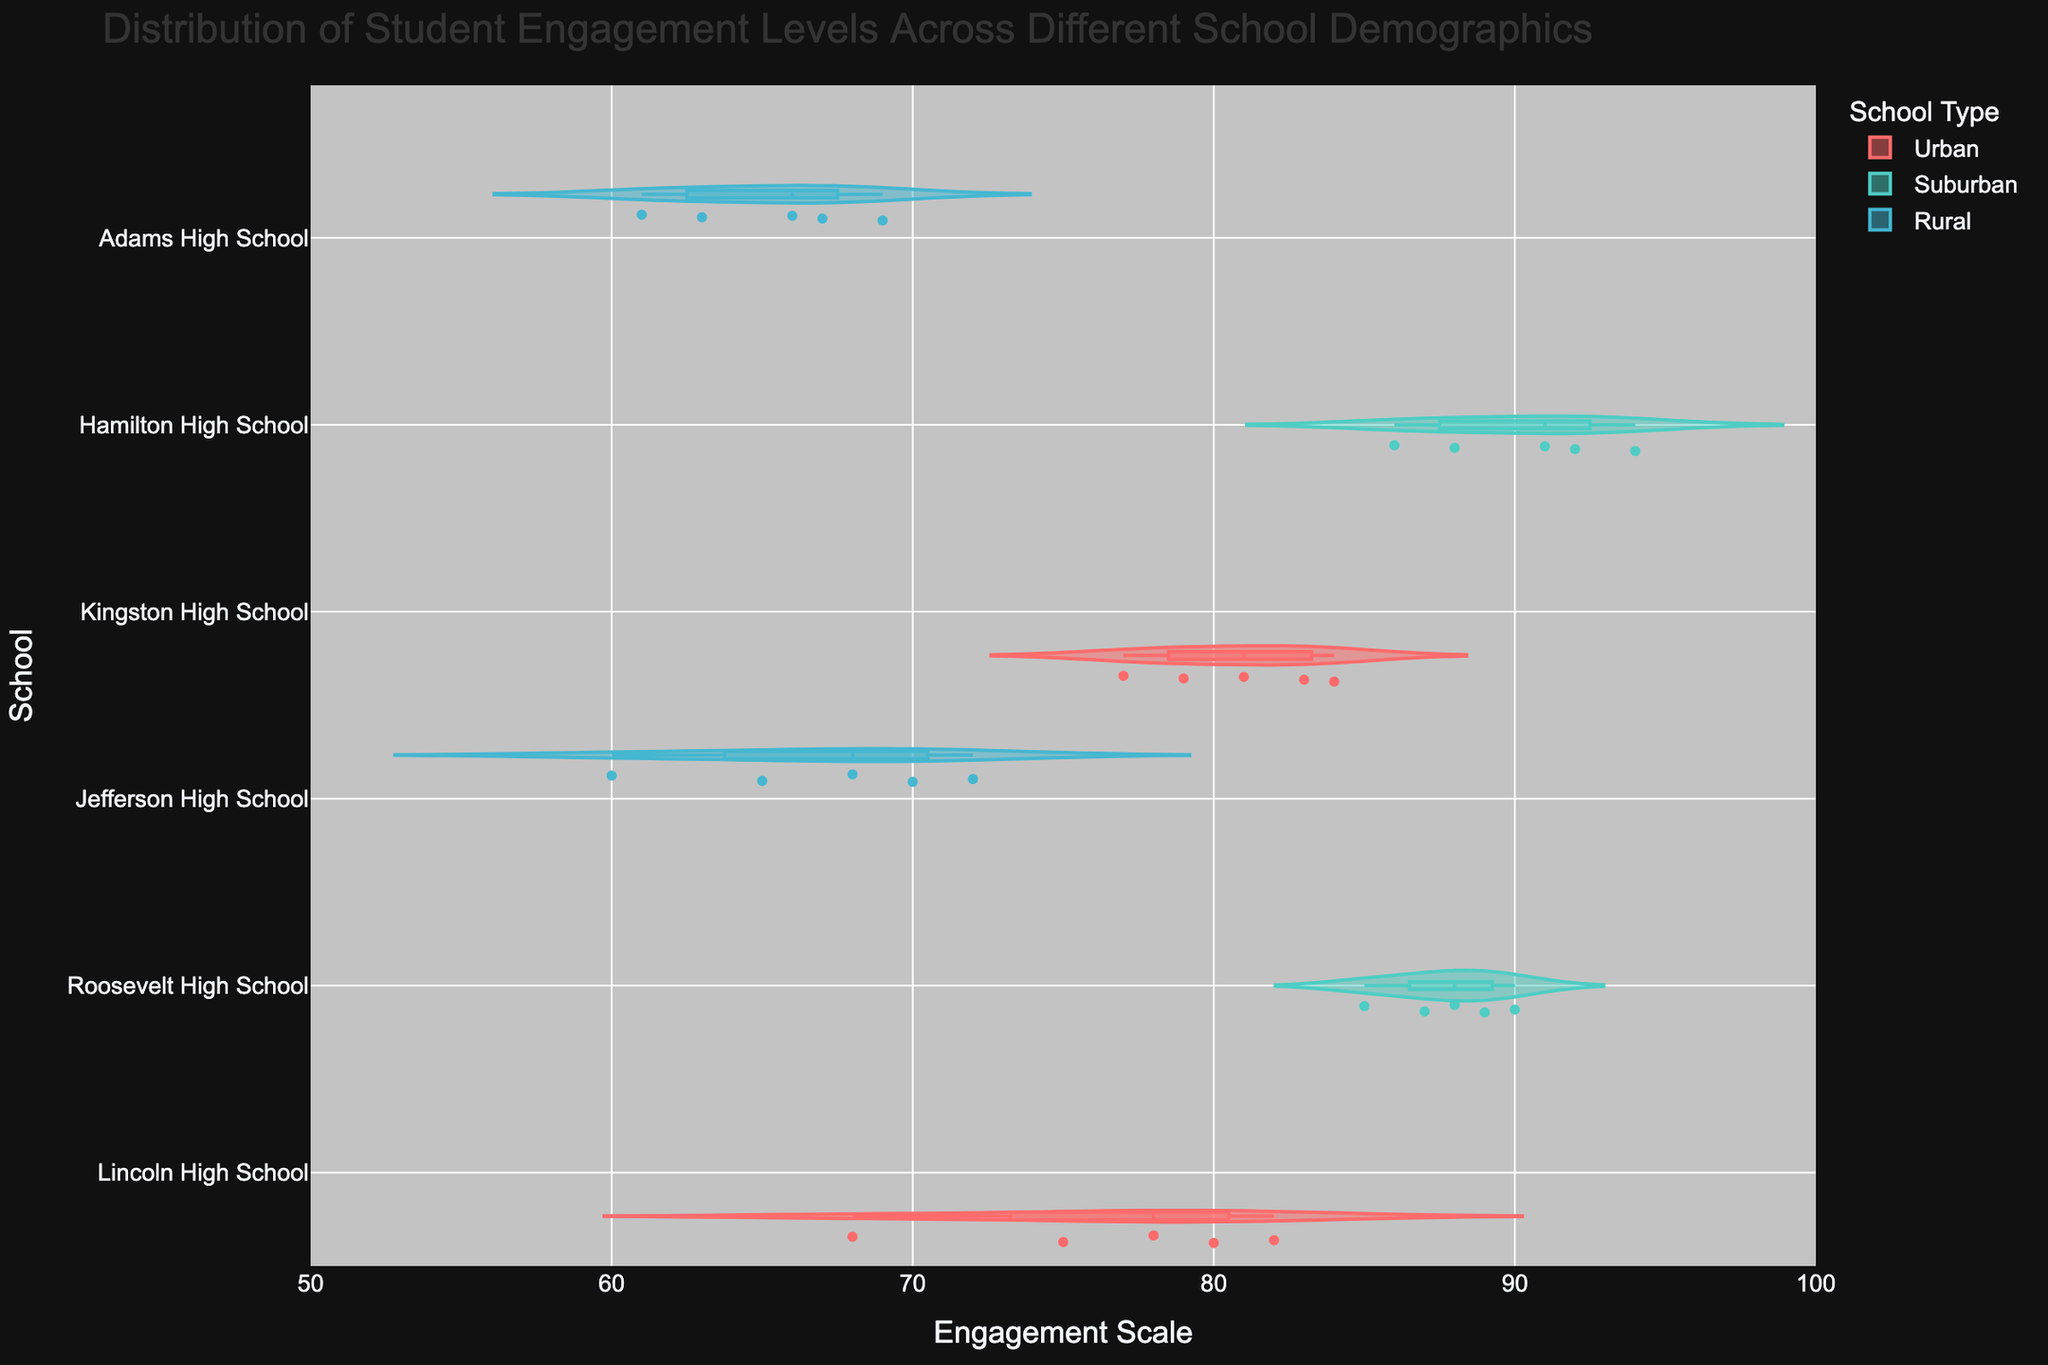Which school has the widest distribution of student engagement levels? The width of the violin plot shows the distribution of engagement levels for each school. The wider the plot, the more varied the engagement levels. By comparing all the schools, Lincoln High School has the widest distribution.
Answer: Lincoln High School What is the median engagement level for Jefferson High School? The median is marked by the line inside the box plot within the violin plot for Jefferson High School. The median engagement level for Jefferson High School is 68.
Answer: 68 How does the engagement level distribution in Adams High School compare to Hamilton High School? By comparing the violin plots for both schools, Adams High School's distribution is narrower, indicating less variance in engagement levels, and the levels are generally lower compared to Hamilton High School, whose distribution is wider and skewed towards higher engagement levels.
Answer: Lower and less varied for Adams; higher and more varied for Hamilton Is the engagement level higher in urban or rural schools on average? The violin plots for urban schools (Lincoln High School and Kingston High School) are centered around higher engagement levels compared to rural schools (Jefferson High School and Adams High School). On average, urban schools have higher engagement levels.
Answer: Urban schools What is the range of engagement levels at Kingston High School? The range can be determined by the minimum and maximum points of the violin plot for Kingston High School. The lowest engagement level is 77 and the highest is 84. Thus, the range is 84 - 77.
Answer: 7 Which school has the highest single engagement level recorded, and what is the level? By examining the violin plots, the highest single engagement level recorded is in Hamilton High School at 94.
Answer: Hamilton High School, 94 How many schools have an engagement level median greater than 80? By checking the median lines inside the box plots, Roosevelt High School and Hamilton High School have medians greater than 80.
Answer: 2 Are there outliers in any of the schools' engagement levels? Outliers can be seen as individual points that are distant from the main distribution within the violin plots. There are no prominent outliers in any of the schools.
Answer: No What is the average engagement level for urban schools? To find the average engagement level for urban schools, sum the engagement levels (78, 68, 82, 75, 80, 81, 77, 83, 79, 84) and divide by the number of data points. The sum is 787 and there are 10 data points, so the average is 787 / 10.
Answer: 78.7 